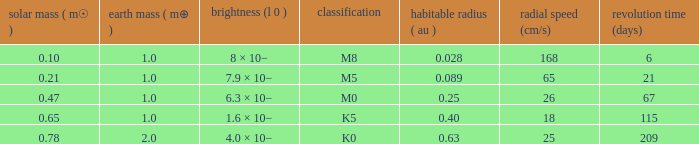What is the total stellar mass of the type m0? 0.47. 